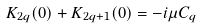<formula> <loc_0><loc_0><loc_500><loc_500>K _ { 2 q } ( 0 ) + K _ { 2 q + 1 } ( 0 ) = - i \mu C _ { q }</formula> 